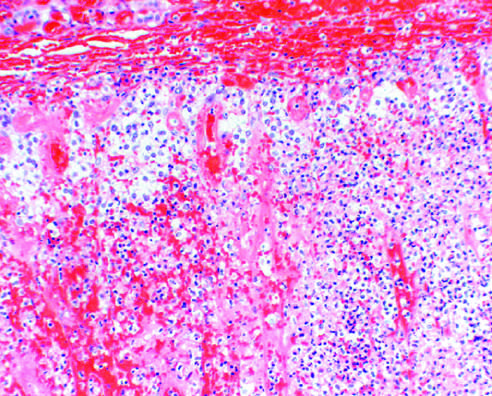were the adrenal glands grossly hemorrhagic and shrunken at autopsy?
Answer the question using a single word or phrase. Yes 